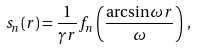<formula> <loc_0><loc_0><loc_500><loc_500>s _ { n } ( r ) = \frac { 1 } { \gamma r } f _ { n } \left ( \frac { \arcsin \omega r } { \omega } \right ) \, ,</formula> 